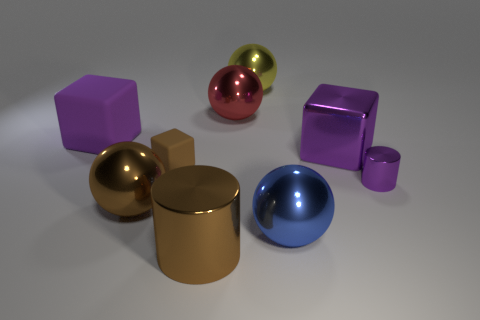How many purple cubes must be subtracted to get 1 purple cubes? 1 Subtract all tiny brown rubber cubes. How many cubes are left? 2 Subtract all blocks. How many objects are left? 6 Subtract 1 balls. How many balls are left? 3 Subtract all gray blocks. Subtract all brown cylinders. How many blocks are left? 3 Subtract all purple cylinders. How many blue balls are left? 1 Subtract all small purple matte spheres. Subtract all big rubber objects. How many objects are left? 8 Add 8 tiny purple things. How many tiny purple things are left? 9 Add 4 blue metallic cylinders. How many blue metallic cylinders exist? 4 Add 1 balls. How many objects exist? 10 